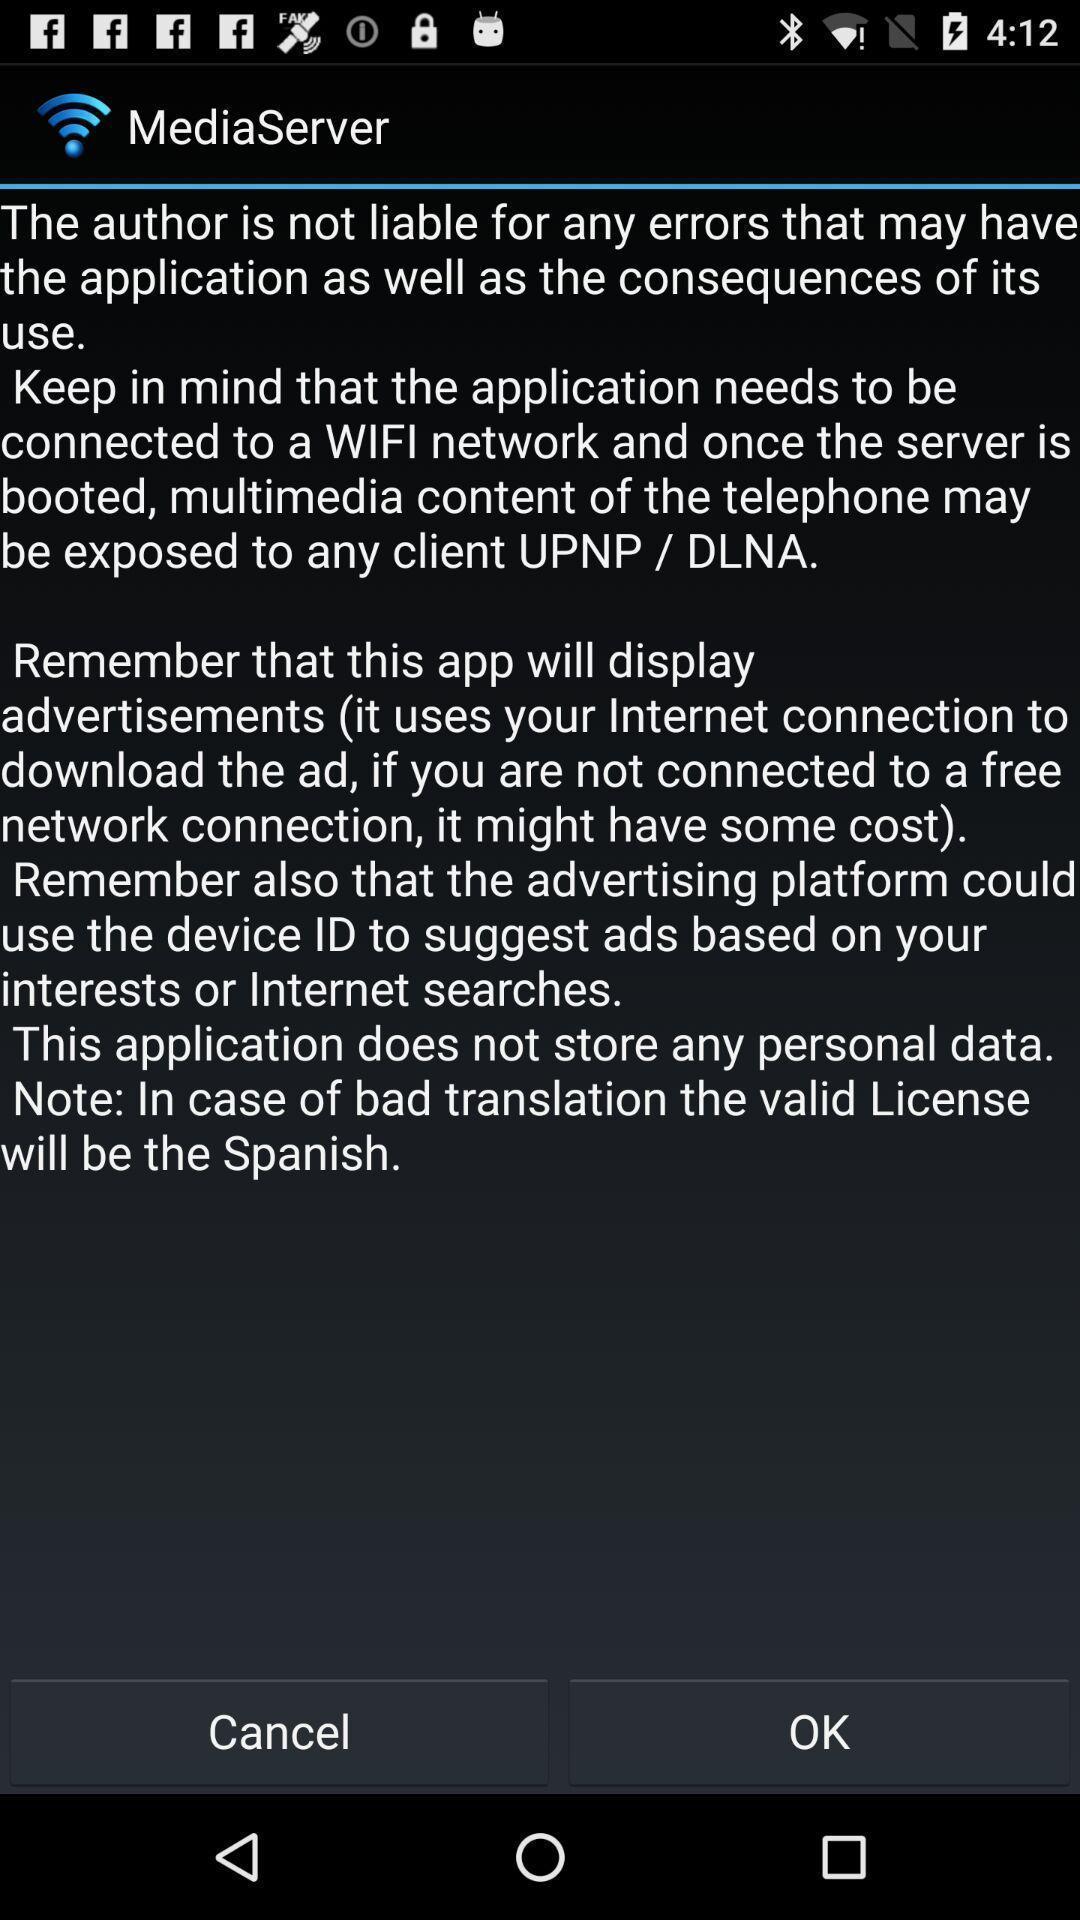Summarize the main components in this picture. Screen displaying information about an application. 